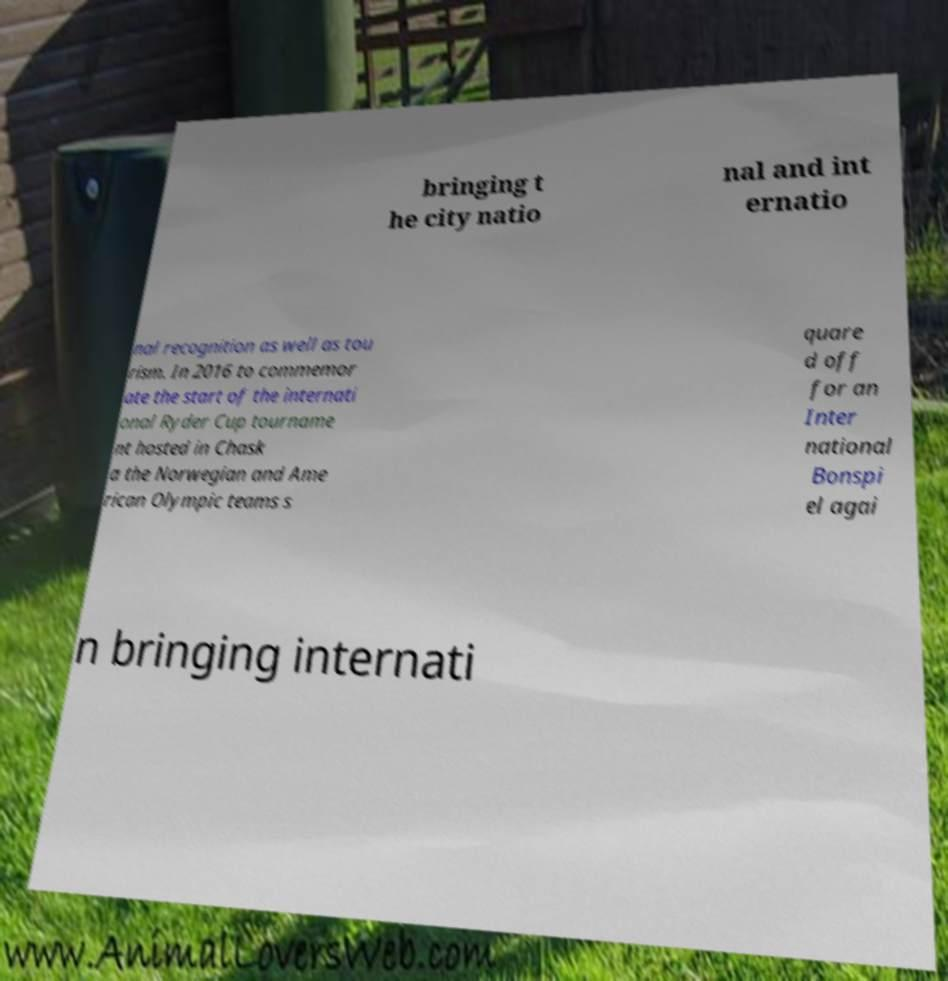Can you accurately transcribe the text from the provided image for me? bringing t he city natio nal and int ernatio nal recognition as well as tou rism. In 2016 to commemor ate the start of the internati onal Ryder Cup tourname nt hosted in Chask a the Norwegian and Ame rican Olympic teams s quare d off for an Inter national Bonspi el agai n bringing internati 